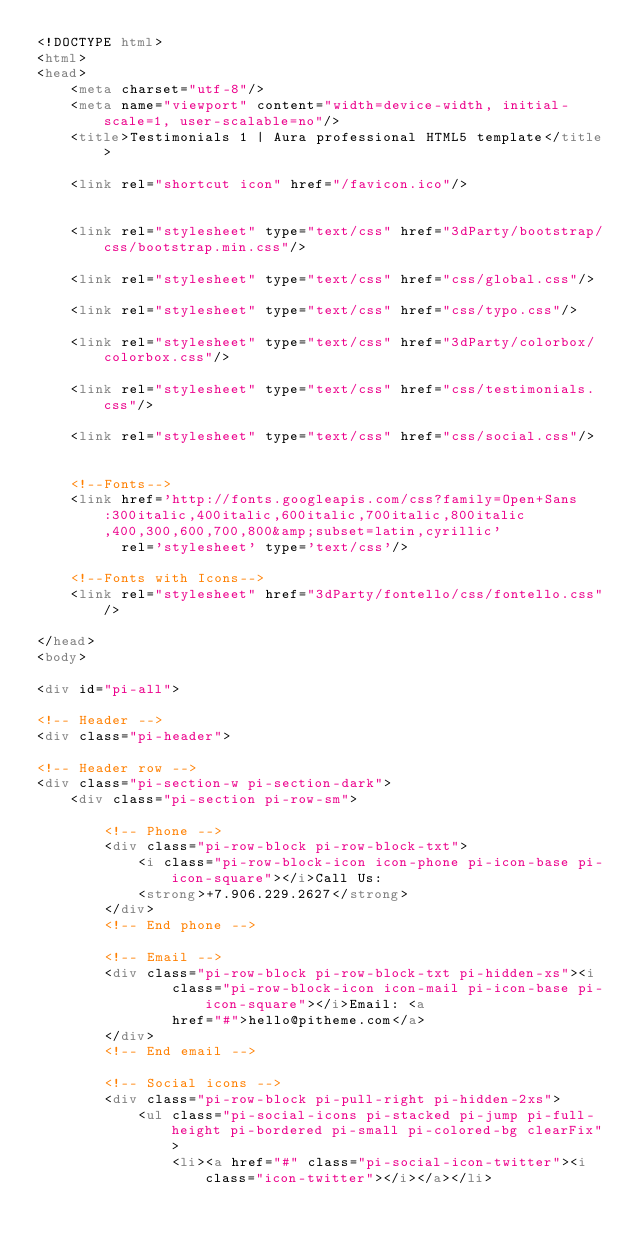Convert code to text. <code><loc_0><loc_0><loc_500><loc_500><_HTML_><!DOCTYPE html>
<html>
<head>
	<meta charset="utf-8"/>
	<meta name="viewport" content="width=device-width, initial-scale=1, user-scalable=no"/>
	<title>Testimonials 1 | Aura professional HTML5 template</title>
	
	<link rel="shortcut icon" href="/favicon.ico"/>

	
	<link rel="stylesheet" type="text/css" href="3dParty/bootstrap/css/bootstrap.min.css"/>
	
	<link rel="stylesheet" type="text/css" href="css/global.css"/>
	
	<link rel="stylesheet" type="text/css" href="css/typo.css"/>
	
	<link rel="stylesheet" type="text/css" href="3dParty/colorbox/colorbox.css"/>
	
	<link rel="stylesheet" type="text/css" href="css/testimonials.css"/>
	
	<link rel="stylesheet" type="text/css" href="css/social.css"/>
	

	<!--Fonts-->
	<link href='http://fonts.googleapis.com/css?family=Open+Sans:300italic,400italic,600italic,700italic,800italic,400,300,600,700,800&amp;subset=latin,cyrillic'
		  rel='stylesheet' type='text/css'/>

	<!--Fonts with Icons-->
	<link rel="stylesheet" href="3dParty/fontello/css/fontello.css"/>

</head>
<body>

<div id="pi-all">

<!-- Header -->
<div class="pi-header">

<!-- Header row -->
<div class="pi-section-w pi-section-dark">
	<div class="pi-section pi-row-sm">

		<!-- Phone -->
		<div class="pi-row-block pi-row-block-txt">
			<i class="pi-row-block-icon icon-phone pi-icon-base pi-icon-square"></i>Call Us:
			<strong>+7.906.229.2627</strong>
		</div>
		<!-- End phone -->

		<!-- Email -->
		<div class="pi-row-block pi-row-block-txt pi-hidden-xs"><i
				class="pi-row-block-icon icon-mail pi-icon-base pi-icon-square"></i>Email: <a
				href="#">hello@pitheme.com</a>
		</div>
		<!-- End email -->

		<!-- Social icons -->
		<div class="pi-row-block pi-pull-right pi-hidden-2xs">
			<ul class="pi-social-icons pi-stacked pi-jump pi-full-height pi-bordered pi-small pi-colored-bg clearFix">
				<li><a href="#" class="pi-social-icon-twitter"><i class="icon-twitter"></i></a></li></code> 